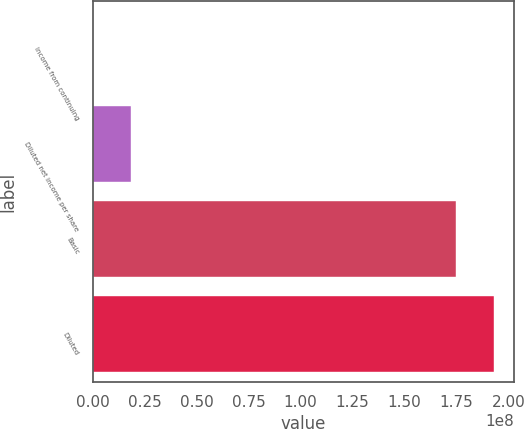Convert chart to OTSL. <chart><loc_0><loc_0><loc_500><loc_500><bar_chart><fcel>Income from continuing<fcel>Diluted net income per share<fcel>Basic<fcel>Diluted<nl><fcel>0.7<fcel>1.82166e+07<fcel>1.74768e+08<fcel>1.92984e+08<nl></chart> 